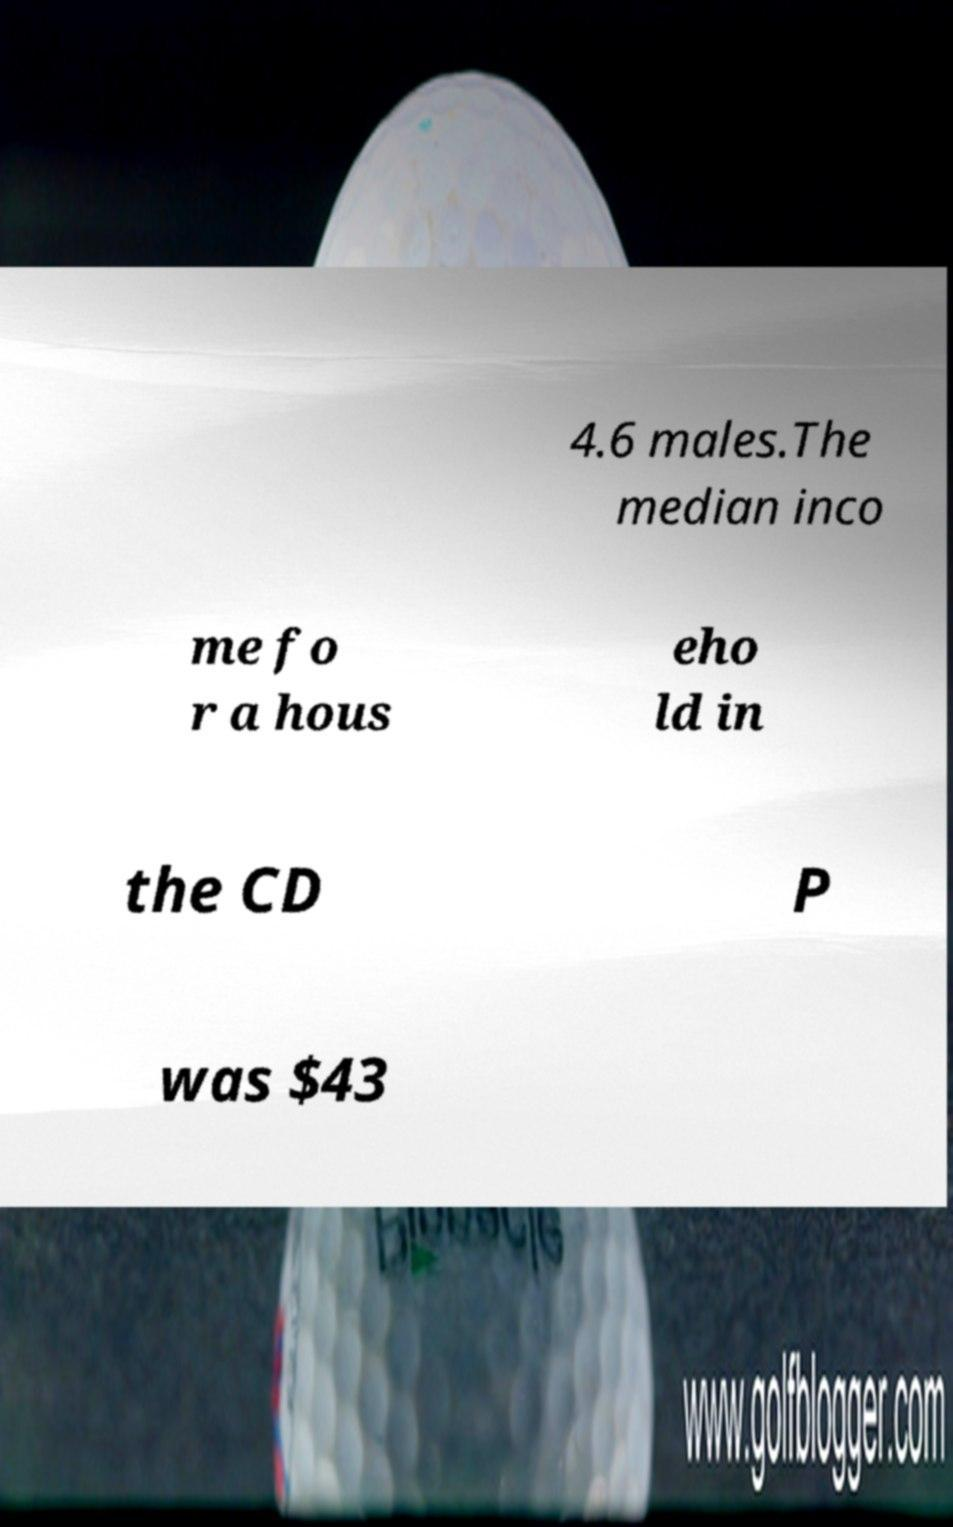Could you extract and type out the text from this image? 4.6 males.The median inco me fo r a hous eho ld in the CD P was $43 